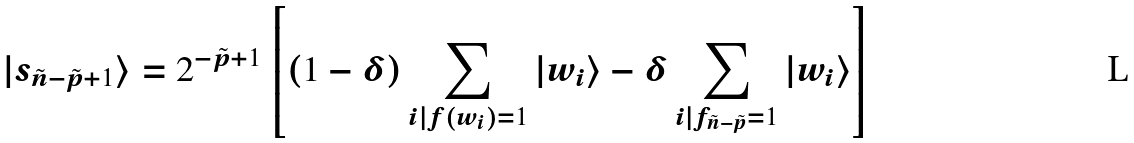Convert formula to latex. <formula><loc_0><loc_0><loc_500><loc_500>| s _ { \tilde { n } - \tilde { p } + 1 } \rangle = 2 ^ { - \tilde { p } + 1 } \left [ ( 1 - \delta ) \sum _ { i | f ( w _ { i } ) = 1 } | w _ { i } \rangle - \delta \sum _ { i | f _ { \tilde { n } - \tilde { p } } = 1 } | w _ { i } \rangle \right ]</formula> 